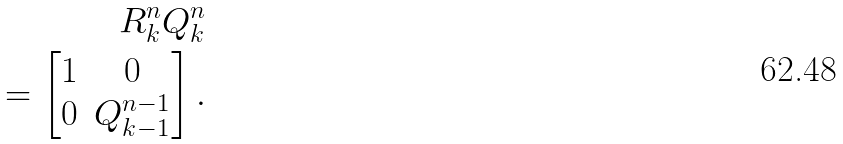Convert formula to latex. <formula><loc_0><loc_0><loc_500><loc_500>R ^ { n } _ { k } Q ^ { n } _ { k } \\ = \left [ \begin{matrix} 1 & 0 \\ 0 & Q ^ { n - 1 } _ { k - 1 } \end{matrix} \right ] .</formula> 